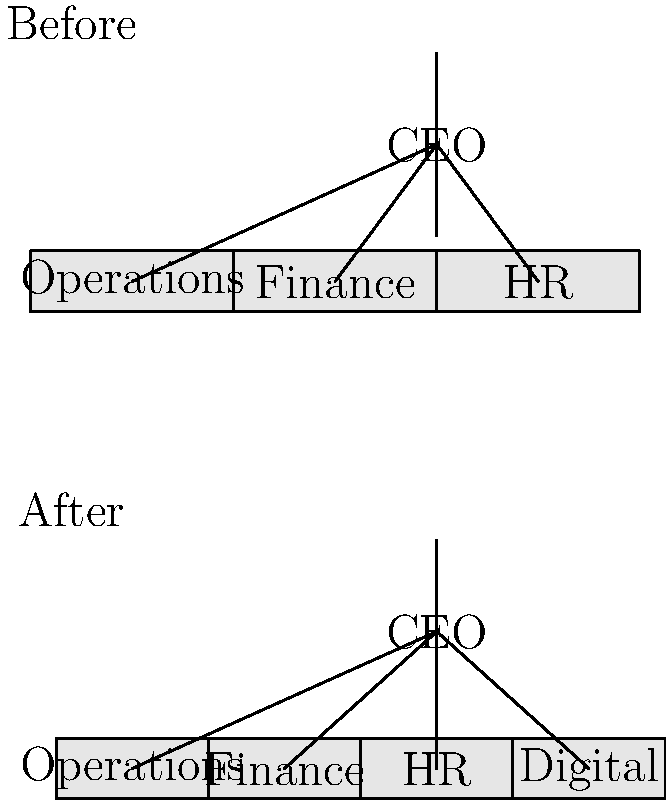Based on the organizational structure changes shown in the before-and-after hierarchical charts, what is the most significant modification made to Axis Bank's structure, and how might this impact the bank's operations? To answer this question, let's analyze the changes in the organizational structure step-by-step:

1. Before the change:
   - The structure shows a CEO at the top.
   - Three main departments report directly to the CEO: Operations, Finance, and HR.

2. After the change:
   - The CEO position remains at the top.
   - The original three departments (Operations, Finance, and HR) are still present.
   - A new department, "Digital," has been added at the same level as the other departments.

3. Significance of the change:
   - The addition of a Digital department indicates that the bank is placing increased emphasis on digital transformation and technology.
   - This new department is likely responsible for overseeing digital banking initiatives, online services, and technological innovations.

4. Impact on bank operations:
   - The Digital department will likely drive modernization efforts across the bank.
   - It may lead to the development of new online and mobile banking services.
   - There could be increased focus on data analytics and digital customer experiences.
   - The change may require collaboration between the new Digital department and existing departments to integrate technology into various aspects of banking operations.

5. Challenges:
   - This structural change may face resistance from long-term employees who are accustomed to traditional banking methods.
   - It will require adaptation and potentially new skills from existing staff members.
   - There might be a need for coordination and clear communication between the new Digital department and other established departments to ensure smooth integration of digital initiatives.

The most significant modification is the addition of the Digital department, which reflects the bank's strategic move towards embracing digital transformation in its operations and services.
Answer: Addition of a Digital department, signaling a strategic shift towards digital transformation in banking operations and services. 